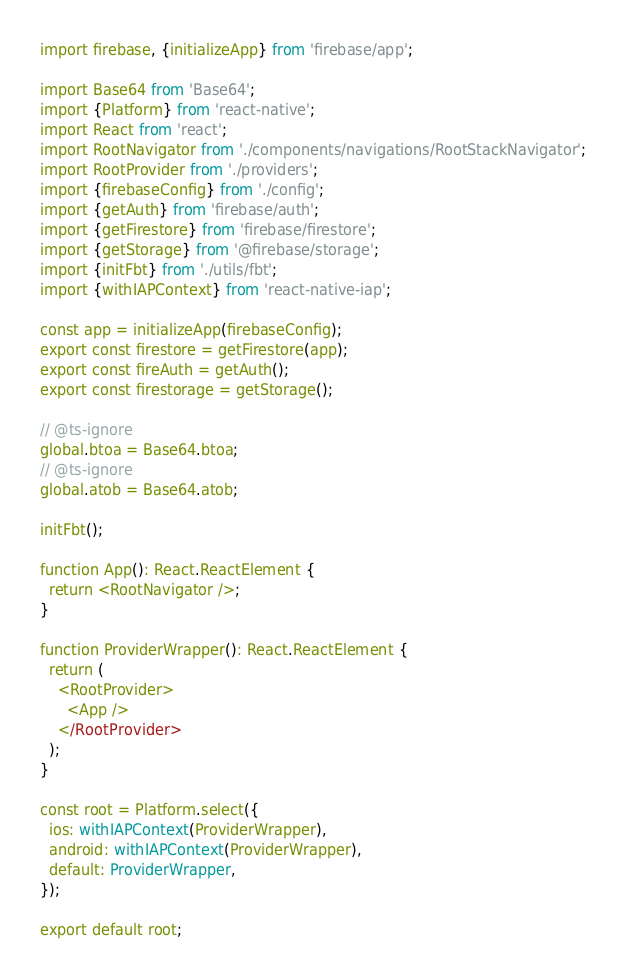Convert code to text. <code><loc_0><loc_0><loc_500><loc_500><_TypeScript_>import firebase, {initializeApp} from 'firebase/app';

import Base64 from 'Base64';
import {Platform} from 'react-native';
import React from 'react';
import RootNavigator from './components/navigations/RootStackNavigator';
import RootProvider from './providers';
import {firebaseConfig} from './config';
import {getAuth} from 'firebase/auth';
import {getFirestore} from 'firebase/firestore';
import {getStorage} from '@firebase/storage';
import {initFbt} from './utils/fbt';
import {withIAPContext} from 'react-native-iap';

const app = initializeApp(firebaseConfig);
export const firestore = getFirestore(app);
export const fireAuth = getAuth();
export const firestorage = getStorage();

// @ts-ignore
global.btoa = Base64.btoa;
// @ts-ignore
global.atob = Base64.atob;

initFbt();

function App(): React.ReactElement {
  return <RootNavigator />;
}

function ProviderWrapper(): React.ReactElement {
  return (
    <RootProvider>
      <App />
    </RootProvider>
  );
}

const root = Platform.select({
  ios: withIAPContext(ProviderWrapper),
  android: withIAPContext(ProviderWrapper),
  default: ProviderWrapper,
});

export default root;
</code> 